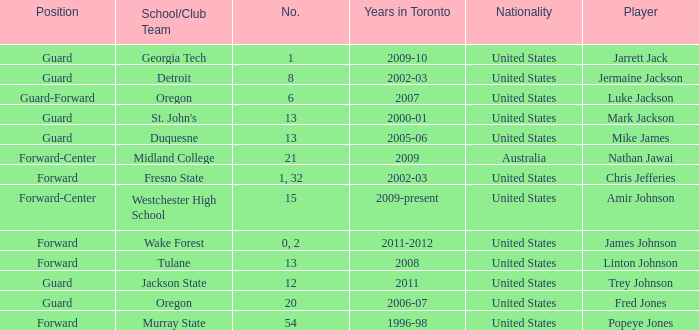Can you parse all the data within this table? {'header': ['Position', 'School/Club Team', 'No.', 'Years in Toronto', 'Nationality', 'Player'], 'rows': [['Guard', 'Georgia Tech', '1', '2009-10', 'United States', 'Jarrett Jack'], ['Guard', 'Detroit', '8', '2002-03', 'United States', 'Jermaine Jackson'], ['Guard-Forward', 'Oregon', '6', '2007', 'United States', 'Luke Jackson'], ['Guard', "St. John's", '13', '2000-01', 'United States', 'Mark Jackson'], ['Guard', 'Duquesne', '13', '2005-06', 'United States', 'Mike James'], ['Forward-Center', 'Midland College', '21', '2009', 'Australia', 'Nathan Jawai'], ['Forward', 'Fresno State', '1, 32', '2002-03', 'United States', 'Chris Jefferies'], ['Forward-Center', 'Westchester High School', '15', '2009-present', 'United States', 'Amir Johnson'], ['Forward', 'Wake Forest', '0, 2', '2011-2012', 'United States', 'James Johnson'], ['Forward', 'Tulane', '13', '2008', 'United States', 'Linton Johnson'], ['Guard', 'Jackson State', '12', '2011', 'United States', 'Trey Johnson'], ['Guard', 'Oregon', '20', '2006-07', 'United States', 'Fred Jones'], ['Forward', 'Murray State', '54', '1996-98', 'United States', 'Popeye Jones']]} What are the nationality of the players on the Fresno State school/club team? United States. 